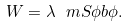Convert formula to latex. <formula><loc_0><loc_0><loc_500><loc_500>W = \lambda \ m S \phi b \phi .</formula> 